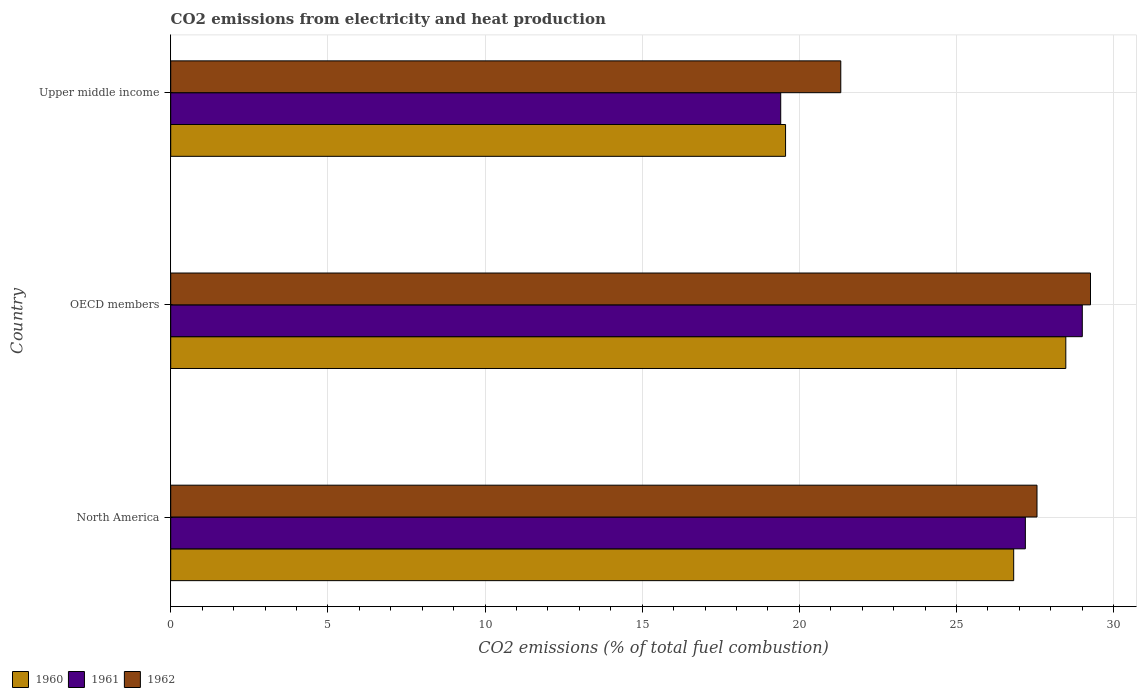How many different coloured bars are there?
Your answer should be compact. 3. Are the number of bars per tick equal to the number of legend labels?
Make the answer very short. Yes. How many bars are there on the 2nd tick from the top?
Your response must be concise. 3. How many bars are there on the 3rd tick from the bottom?
Keep it short and to the point. 3. In how many cases, is the number of bars for a given country not equal to the number of legend labels?
Your response must be concise. 0. What is the amount of CO2 emitted in 1962 in Upper middle income?
Offer a very short reply. 21.32. Across all countries, what is the maximum amount of CO2 emitted in 1962?
Ensure brevity in your answer.  29.26. Across all countries, what is the minimum amount of CO2 emitted in 1962?
Your answer should be very brief. 21.32. In which country was the amount of CO2 emitted in 1961 maximum?
Offer a very short reply. OECD members. In which country was the amount of CO2 emitted in 1961 minimum?
Provide a short and direct response. Upper middle income. What is the total amount of CO2 emitted in 1962 in the graph?
Provide a short and direct response. 78.15. What is the difference between the amount of CO2 emitted in 1960 in OECD members and that in Upper middle income?
Offer a terse response. 8.92. What is the difference between the amount of CO2 emitted in 1961 in Upper middle income and the amount of CO2 emitted in 1962 in North America?
Your answer should be compact. -8.15. What is the average amount of CO2 emitted in 1961 per country?
Provide a succinct answer. 25.2. What is the difference between the amount of CO2 emitted in 1961 and amount of CO2 emitted in 1962 in OECD members?
Provide a succinct answer. -0.26. In how many countries, is the amount of CO2 emitted in 1962 greater than 15 %?
Offer a very short reply. 3. What is the ratio of the amount of CO2 emitted in 1961 in OECD members to that in Upper middle income?
Provide a succinct answer. 1.49. What is the difference between the highest and the second highest amount of CO2 emitted in 1960?
Ensure brevity in your answer.  1.66. What is the difference between the highest and the lowest amount of CO2 emitted in 1960?
Offer a very short reply. 8.92. In how many countries, is the amount of CO2 emitted in 1960 greater than the average amount of CO2 emitted in 1960 taken over all countries?
Offer a very short reply. 2. Is the sum of the amount of CO2 emitted in 1961 in North America and OECD members greater than the maximum amount of CO2 emitted in 1960 across all countries?
Your answer should be compact. Yes. What does the 2nd bar from the top in North America represents?
Provide a succinct answer. 1961. Is it the case that in every country, the sum of the amount of CO2 emitted in 1961 and amount of CO2 emitted in 1962 is greater than the amount of CO2 emitted in 1960?
Offer a very short reply. Yes. How many bars are there?
Provide a short and direct response. 9. Are all the bars in the graph horizontal?
Your response must be concise. Yes. Are the values on the major ticks of X-axis written in scientific E-notation?
Offer a terse response. No. Does the graph contain any zero values?
Offer a very short reply. No. Does the graph contain grids?
Make the answer very short. Yes. What is the title of the graph?
Provide a succinct answer. CO2 emissions from electricity and heat production. Does "1979" appear as one of the legend labels in the graph?
Offer a terse response. No. What is the label or title of the X-axis?
Offer a terse response. CO2 emissions (% of total fuel combustion). What is the CO2 emissions (% of total fuel combustion) in 1960 in North America?
Make the answer very short. 26.82. What is the CO2 emissions (% of total fuel combustion) in 1961 in North America?
Make the answer very short. 27.19. What is the CO2 emissions (% of total fuel combustion) in 1962 in North America?
Your response must be concise. 27.56. What is the CO2 emissions (% of total fuel combustion) of 1960 in OECD members?
Provide a short and direct response. 28.48. What is the CO2 emissions (% of total fuel combustion) of 1961 in OECD members?
Your response must be concise. 29. What is the CO2 emissions (% of total fuel combustion) of 1962 in OECD members?
Your response must be concise. 29.26. What is the CO2 emissions (% of total fuel combustion) in 1960 in Upper middle income?
Provide a succinct answer. 19.56. What is the CO2 emissions (% of total fuel combustion) in 1961 in Upper middle income?
Offer a very short reply. 19.41. What is the CO2 emissions (% of total fuel combustion) of 1962 in Upper middle income?
Provide a succinct answer. 21.32. Across all countries, what is the maximum CO2 emissions (% of total fuel combustion) in 1960?
Your answer should be very brief. 28.48. Across all countries, what is the maximum CO2 emissions (% of total fuel combustion) of 1961?
Offer a very short reply. 29. Across all countries, what is the maximum CO2 emissions (% of total fuel combustion) in 1962?
Make the answer very short. 29.26. Across all countries, what is the minimum CO2 emissions (% of total fuel combustion) in 1960?
Your response must be concise. 19.56. Across all countries, what is the minimum CO2 emissions (% of total fuel combustion) in 1961?
Your answer should be compact. 19.41. Across all countries, what is the minimum CO2 emissions (% of total fuel combustion) in 1962?
Ensure brevity in your answer.  21.32. What is the total CO2 emissions (% of total fuel combustion) of 1960 in the graph?
Offer a terse response. 74.86. What is the total CO2 emissions (% of total fuel combustion) of 1961 in the graph?
Make the answer very short. 75.6. What is the total CO2 emissions (% of total fuel combustion) in 1962 in the graph?
Keep it short and to the point. 78.15. What is the difference between the CO2 emissions (% of total fuel combustion) of 1960 in North America and that in OECD members?
Make the answer very short. -1.66. What is the difference between the CO2 emissions (% of total fuel combustion) of 1961 in North America and that in OECD members?
Your answer should be very brief. -1.81. What is the difference between the CO2 emissions (% of total fuel combustion) in 1962 in North America and that in OECD members?
Give a very brief answer. -1.7. What is the difference between the CO2 emissions (% of total fuel combustion) of 1960 in North America and that in Upper middle income?
Provide a short and direct response. 7.26. What is the difference between the CO2 emissions (% of total fuel combustion) of 1961 in North America and that in Upper middle income?
Ensure brevity in your answer.  7.78. What is the difference between the CO2 emissions (% of total fuel combustion) in 1962 in North America and that in Upper middle income?
Keep it short and to the point. 6.24. What is the difference between the CO2 emissions (% of total fuel combustion) of 1960 in OECD members and that in Upper middle income?
Provide a succinct answer. 8.92. What is the difference between the CO2 emissions (% of total fuel combustion) of 1961 in OECD members and that in Upper middle income?
Provide a short and direct response. 9.6. What is the difference between the CO2 emissions (% of total fuel combustion) of 1962 in OECD members and that in Upper middle income?
Keep it short and to the point. 7.95. What is the difference between the CO2 emissions (% of total fuel combustion) in 1960 in North America and the CO2 emissions (% of total fuel combustion) in 1961 in OECD members?
Offer a very short reply. -2.18. What is the difference between the CO2 emissions (% of total fuel combustion) in 1960 in North America and the CO2 emissions (% of total fuel combustion) in 1962 in OECD members?
Offer a terse response. -2.44. What is the difference between the CO2 emissions (% of total fuel combustion) of 1961 in North America and the CO2 emissions (% of total fuel combustion) of 1962 in OECD members?
Offer a terse response. -2.07. What is the difference between the CO2 emissions (% of total fuel combustion) in 1960 in North America and the CO2 emissions (% of total fuel combustion) in 1961 in Upper middle income?
Make the answer very short. 7.41. What is the difference between the CO2 emissions (% of total fuel combustion) in 1960 in North America and the CO2 emissions (% of total fuel combustion) in 1962 in Upper middle income?
Give a very brief answer. 5.5. What is the difference between the CO2 emissions (% of total fuel combustion) in 1961 in North America and the CO2 emissions (% of total fuel combustion) in 1962 in Upper middle income?
Make the answer very short. 5.87. What is the difference between the CO2 emissions (% of total fuel combustion) of 1960 in OECD members and the CO2 emissions (% of total fuel combustion) of 1961 in Upper middle income?
Keep it short and to the point. 9.07. What is the difference between the CO2 emissions (% of total fuel combustion) in 1960 in OECD members and the CO2 emissions (% of total fuel combustion) in 1962 in Upper middle income?
Keep it short and to the point. 7.16. What is the difference between the CO2 emissions (% of total fuel combustion) of 1961 in OECD members and the CO2 emissions (% of total fuel combustion) of 1962 in Upper middle income?
Provide a succinct answer. 7.68. What is the average CO2 emissions (% of total fuel combustion) of 1960 per country?
Offer a terse response. 24.95. What is the average CO2 emissions (% of total fuel combustion) in 1961 per country?
Make the answer very short. 25.2. What is the average CO2 emissions (% of total fuel combustion) of 1962 per country?
Provide a short and direct response. 26.05. What is the difference between the CO2 emissions (% of total fuel combustion) in 1960 and CO2 emissions (% of total fuel combustion) in 1961 in North America?
Give a very brief answer. -0.37. What is the difference between the CO2 emissions (% of total fuel combustion) of 1960 and CO2 emissions (% of total fuel combustion) of 1962 in North America?
Make the answer very short. -0.74. What is the difference between the CO2 emissions (% of total fuel combustion) of 1961 and CO2 emissions (% of total fuel combustion) of 1962 in North America?
Ensure brevity in your answer.  -0.37. What is the difference between the CO2 emissions (% of total fuel combustion) in 1960 and CO2 emissions (% of total fuel combustion) in 1961 in OECD members?
Ensure brevity in your answer.  -0.52. What is the difference between the CO2 emissions (% of total fuel combustion) in 1960 and CO2 emissions (% of total fuel combustion) in 1962 in OECD members?
Make the answer very short. -0.79. What is the difference between the CO2 emissions (% of total fuel combustion) of 1961 and CO2 emissions (% of total fuel combustion) of 1962 in OECD members?
Make the answer very short. -0.26. What is the difference between the CO2 emissions (% of total fuel combustion) of 1960 and CO2 emissions (% of total fuel combustion) of 1961 in Upper middle income?
Give a very brief answer. 0.15. What is the difference between the CO2 emissions (% of total fuel combustion) in 1960 and CO2 emissions (% of total fuel combustion) in 1962 in Upper middle income?
Give a very brief answer. -1.76. What is the difference between the CO2 emissions (% of total fuel combustion) in 1961 and CO2 emissions (% of total fuel combustion) in 1962 in Upper middle income?
Provide a succinct answer. -1.91. What is the ratio of the CO2 emissions (% of total fuel combustion) of 1960 in North America to that in OECD members?
Keep it short and to the point. 0.94. What is the ratio of the CO2 emissions (% of total fuel combustion) of 1962 in North America to that in OECD members?
Give a very brief answer. 0.94. What is the ratio of the CO2 emissions (% of total fuel combustion) of 1960 in North America to that in Upper middle income?
Offer a terse response. 1.37. What is the ratio of the CO2 emissions (% of total fuel combustion) in 1961 in North America to that in Upper middle income?
Offer a very short reply. 1.4. What is the ratio of the CO2 emissions (% of total fuel combustion) in 1962 in North America to that in Upper middle income?
Keep it short and to the point. 1.29. What is the ratio of the CO2 emissions (% of total fuel combustion) in 1960 in OECD members to that in Upper middle income?
Your response must be concise. 1.46. What is the ratio of the CO2 emissions (% of total fuel combustion) in 1961 in OECD members to that in Upper middle income?
Offer a very short reply. 1.49. What is the ratio of the CO2 emissions (% of total fuel combustion) in 1962 in OECD members to that in Upper middle income?
Your response must be concise. 1.37. What is the difference between the highest and the second highest CO2 emissions (% of total fuel combustion) in 1960?
Your response must be concise. 1.66. What is the difference between the highest and the second highest CO2 emissions (% of total fuel combustion) of 1961?
Make the answer very short. 1.81. What is the difference between the highest and the second highest CO2 emissions (% of total fuel combustion) of 1962?
Your answer should be compact. 1.7. What is the difference between the highest and the lowest CO2 emissions (% of total fuel combustion) of 1960?
Provide a succinct answer. 8.92. What is the difference between the highest and the lowest CO2 emissions (% of total fuel combustion) of 1961?
Ensure brevity in your answer.  9.6. What is the difference between the highest and the lowest CO2 emissions (% of total fuel combustion) in 1962?
Your response must be concise. 7.95. 